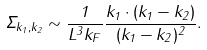Convert formula to latex. <formula><loc_0><loc_0><loc_500><loc_500>\Sigma _ { { k } _ { 1 } , { k } _ { 2 } } \sim \frac { 1 } { L ^ { 3 } k _ { F } } \frac { { k } _ { 1 } \cdot ( { k } _ { 1 } - { k } _ { 2 } ) } { ( { k } _ { 1 } - { k } _ { 2 } ) ^ { 2 } } .</formula> 